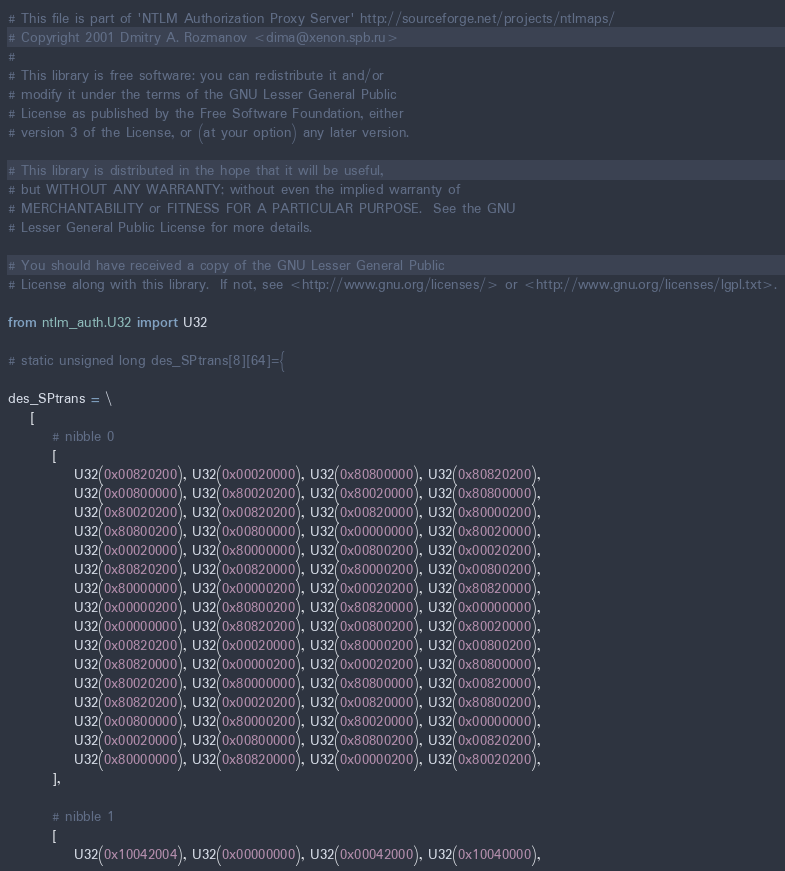<code> <loc_0><loc_0><loc_500><loc_500><_Python_># This file is part of 'NTLM Authorization Proxy Server' http://sourceforge.net/projects/ntlmaps/
# Copyright 2001 Dmitry A. Rozmanov <dima@xenon.spb.ru>
#
# This library is free software: you can redistribute it and/or
# modify it under the terms of the GNU Lesser General Public
# License as published by the Free Software Foundation, either
# version 3 of the License, or (at your option) any later version.

# This library is distributed in the hope that it will be useful,
# but WITHOUT ANY WARRANTY; without even the implied warranty of
# MERCHANTABILITY or FITNESS FOR A PARTICULAR PURPOSE.  See the GNU
# Lesser General Public License for more details.

# You should have received a copy of the GNU Lesser General Public
# License along with this library.  If not, see <http://www.gnu.org/licenses/> or <http://www.gnu.org/licenses/lgpl.txt>.

from ntlm_auth.U32 import U32

# static unsigned long des_SPtrans[8][64]={

des_SPtrans = \
    [
        # nibble 0
        [
            U32(0x00820200), U32(0x00020000), U32(0x80800000), U32(0x80820200),
            U32(0x00800000), U32(0x80020200), U32(0x80020000), U32(0x80800000),
            U32(0x80020200), U32(0x00820200), U32(0x00820000), U32(0x80000200),
            U32(0x80800200), U32(0x00800000), U32(0x00000000), U32(0x80020000),
            U32(0x00020000), U32(0x80000000), U32(0x00800200), U32(0x00020200),
            U32(0x80820200), U32(0x00820000), U32(0x80000200), U32(0x00800200),
            U32(0x80000000), U32(0x00000200), U32(0x00020200), U32(0x80820000),
            U32(0x00000200), U32(0x80800200), U32(0x80820000), U32(0x00000000),
            U32(0x00000000), U32(0x80820200), U32(0x00800200), U32(0x80020000),
            U32(0x00820200), U32(0x00020000), U32(0x80000200), U32(0x00800200),
            U32(0x80820000), U32(0x00000200), U32(0x00020200), U32(0x80800000),
            U32(0x80020200), U32(0x80000000), U32(0x80800000), U32(0x00820000),
            U32(0x80820200), U32(0x00020200), U32(0x00820000), U32(0x80800200),
            U32(0x00800000), U32(0x80000200), U32(0x80020000), U32(0x00000000),
            U32(0x00020000), U32(0x00800000), U32(0x80800200), U32(0x00820200),
            U32(0x80000000), U32(0x80820000), U32(0x00000200), U32(0x80020200),
        ],

        # nibble 1
        [
            U32(0x10042004), U32(0x00000000), U32(0x00042000), U32(0x10040000),</code> 